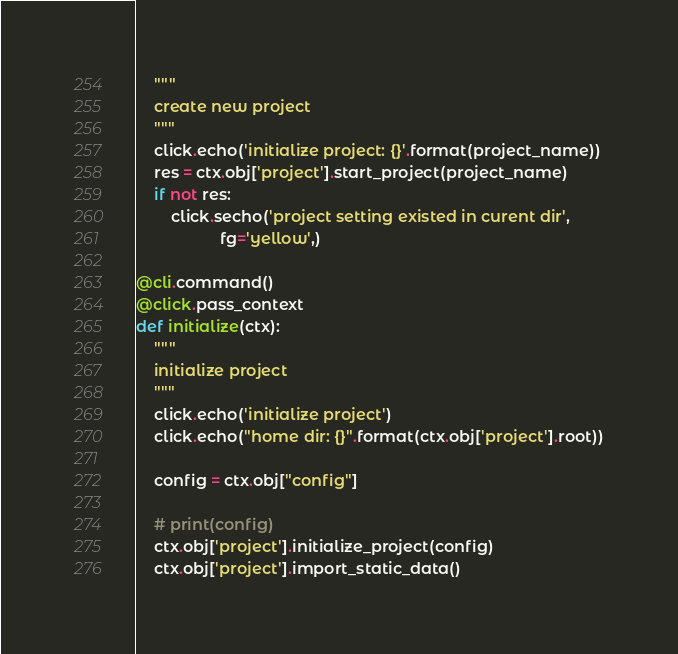<code> <loc_0><loc_0><loc_500><loc_500><_Python_>    """
    create new project
    """
    click.echo('initialize project: {}'.format(project_name))
    res = ctx.obj['project'].start_project(project_name)
    if not res:
        click.secho('project setting existed in curent dir',
                   fg='yellow',)

@cli.command()
@click.pass_context
def initialize(ctx):
    """
    initialize project
    """
    click.echo('initialize project')
    click.echo("home dir: {}".format(ctx.obj['project'].root))
    
    config = ctx.obj["config"]
    
    # print(config)
    ctx.obj['project'].initialize_project(config)
    ctx.obj['project'].import_static_data()

</code> 